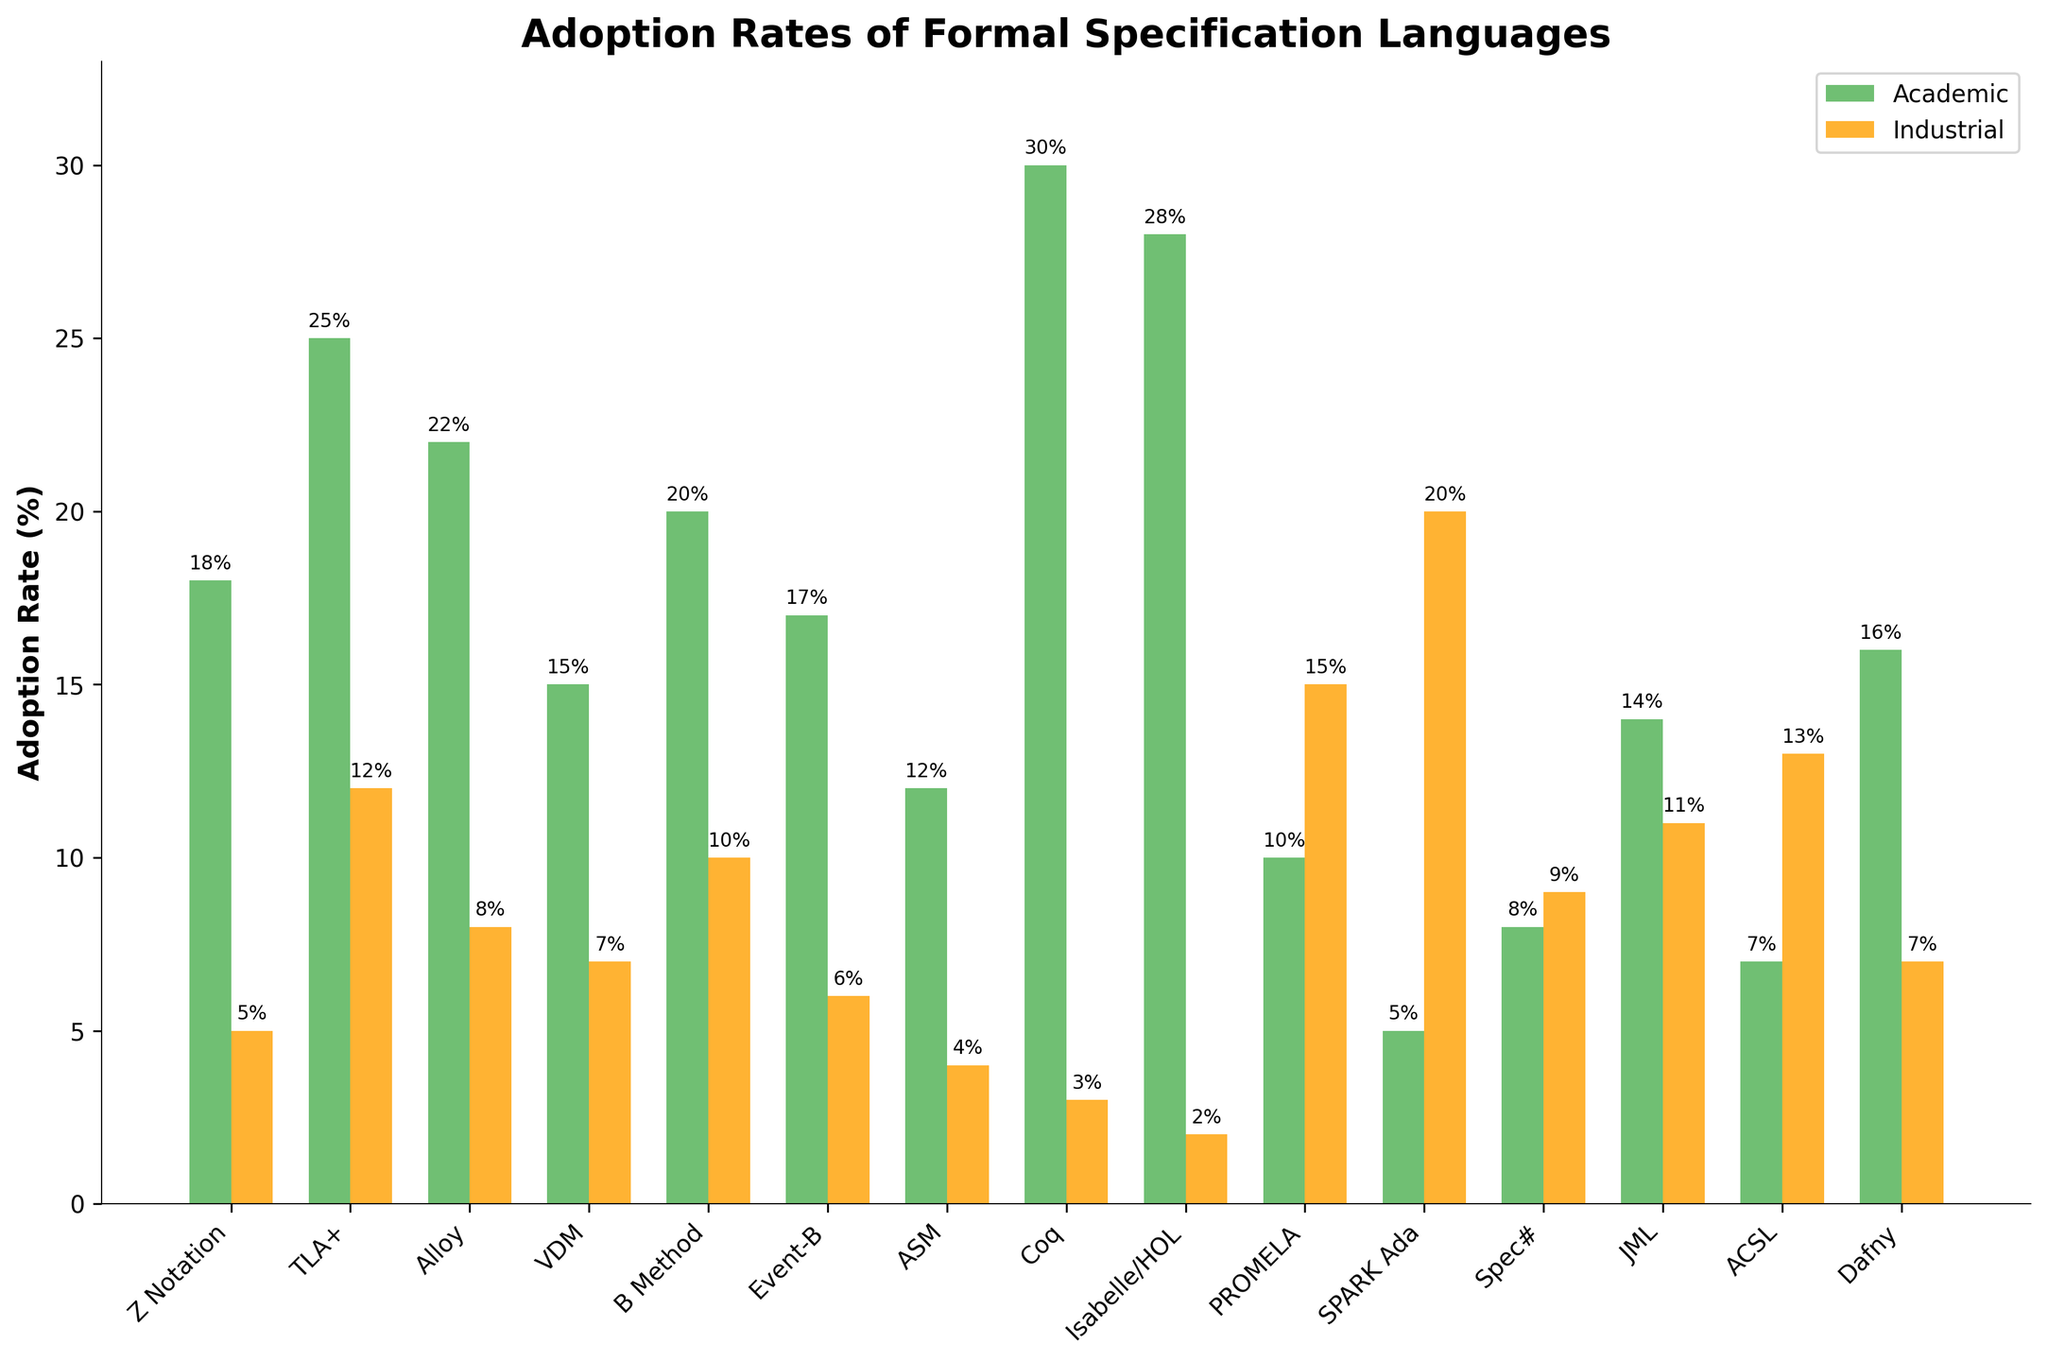Which language has the highest academic adoption rate? By visually inspecting the bar chart, we see that the tallest green bar, representing academic adoption, belongs to Coq.
Answer: Coq Which language is more adopted in industrial settings than academic ones? By comparing the heights of the pairs of bars for each language, PROMELA and SPARK Ada are the only languages where the orange bar (industrial) is taller than the green bar (academic).
Answer: PROMELA and SPARK Ada What is the combined adoption rate (academic + industrial) for TLA+? Adding the heights of the green and orange bars for TLA+, we get 25% (academic) + 12% (industrial).
Answer: 37% How does the academic adoption rate of Alloy compare to that of VDM? By comparing the heights of the green bars for Alloy and VDM, Alloy (22%) has a higher academic adoption rate than VDM (15%).
Answer: Alloy is higher Which language is only weakly adopted in both academic and industrial settings? Checking for the languages with the smallest combined bar heights, Coq has the lowest industrial adoption at 3% but does not fit the weak adoption in academic. Instead, languages like Spec# (8% academic, 9% industrial) and ASM (12% academic, 4% industrial) have less noticeable bars.
Answer: Spec# and ASM How does the industrial adoption rate of Isabelle/HOL compare with that of Spec#? Comparing the heights of the orange bars for Isabelle/HOL (2%) and Spec# (9%), Spec# has a higher industrial adoption rate.
Answer: Spec# is higher What is the difference in industrial adoption rates between PROMELA and ACSL? Subtracting the height of the ACSL bar from the height of the PROMELA bar: 15% (PROMELA) - 13% (ACSL).
Answer: 2% Is the adoption rate of B Method higher in academia or industry? Comparing the heights of the green and orange bars for B Method, the green bar (academic, 20%) is taller than the orange bar (industrial, 10%).
Answer: Academia What is the median academic adoption rate among all languages? Ordering the academic adoption rates: 5%, 7%, 8%, 10%, 12%, 14%, 15%, 16%, 17%, 18%, 20%, 22%, 25%, 28%, 30%. The median is the 8th value in an ordered list, which is 16%.
Answer: 16% 